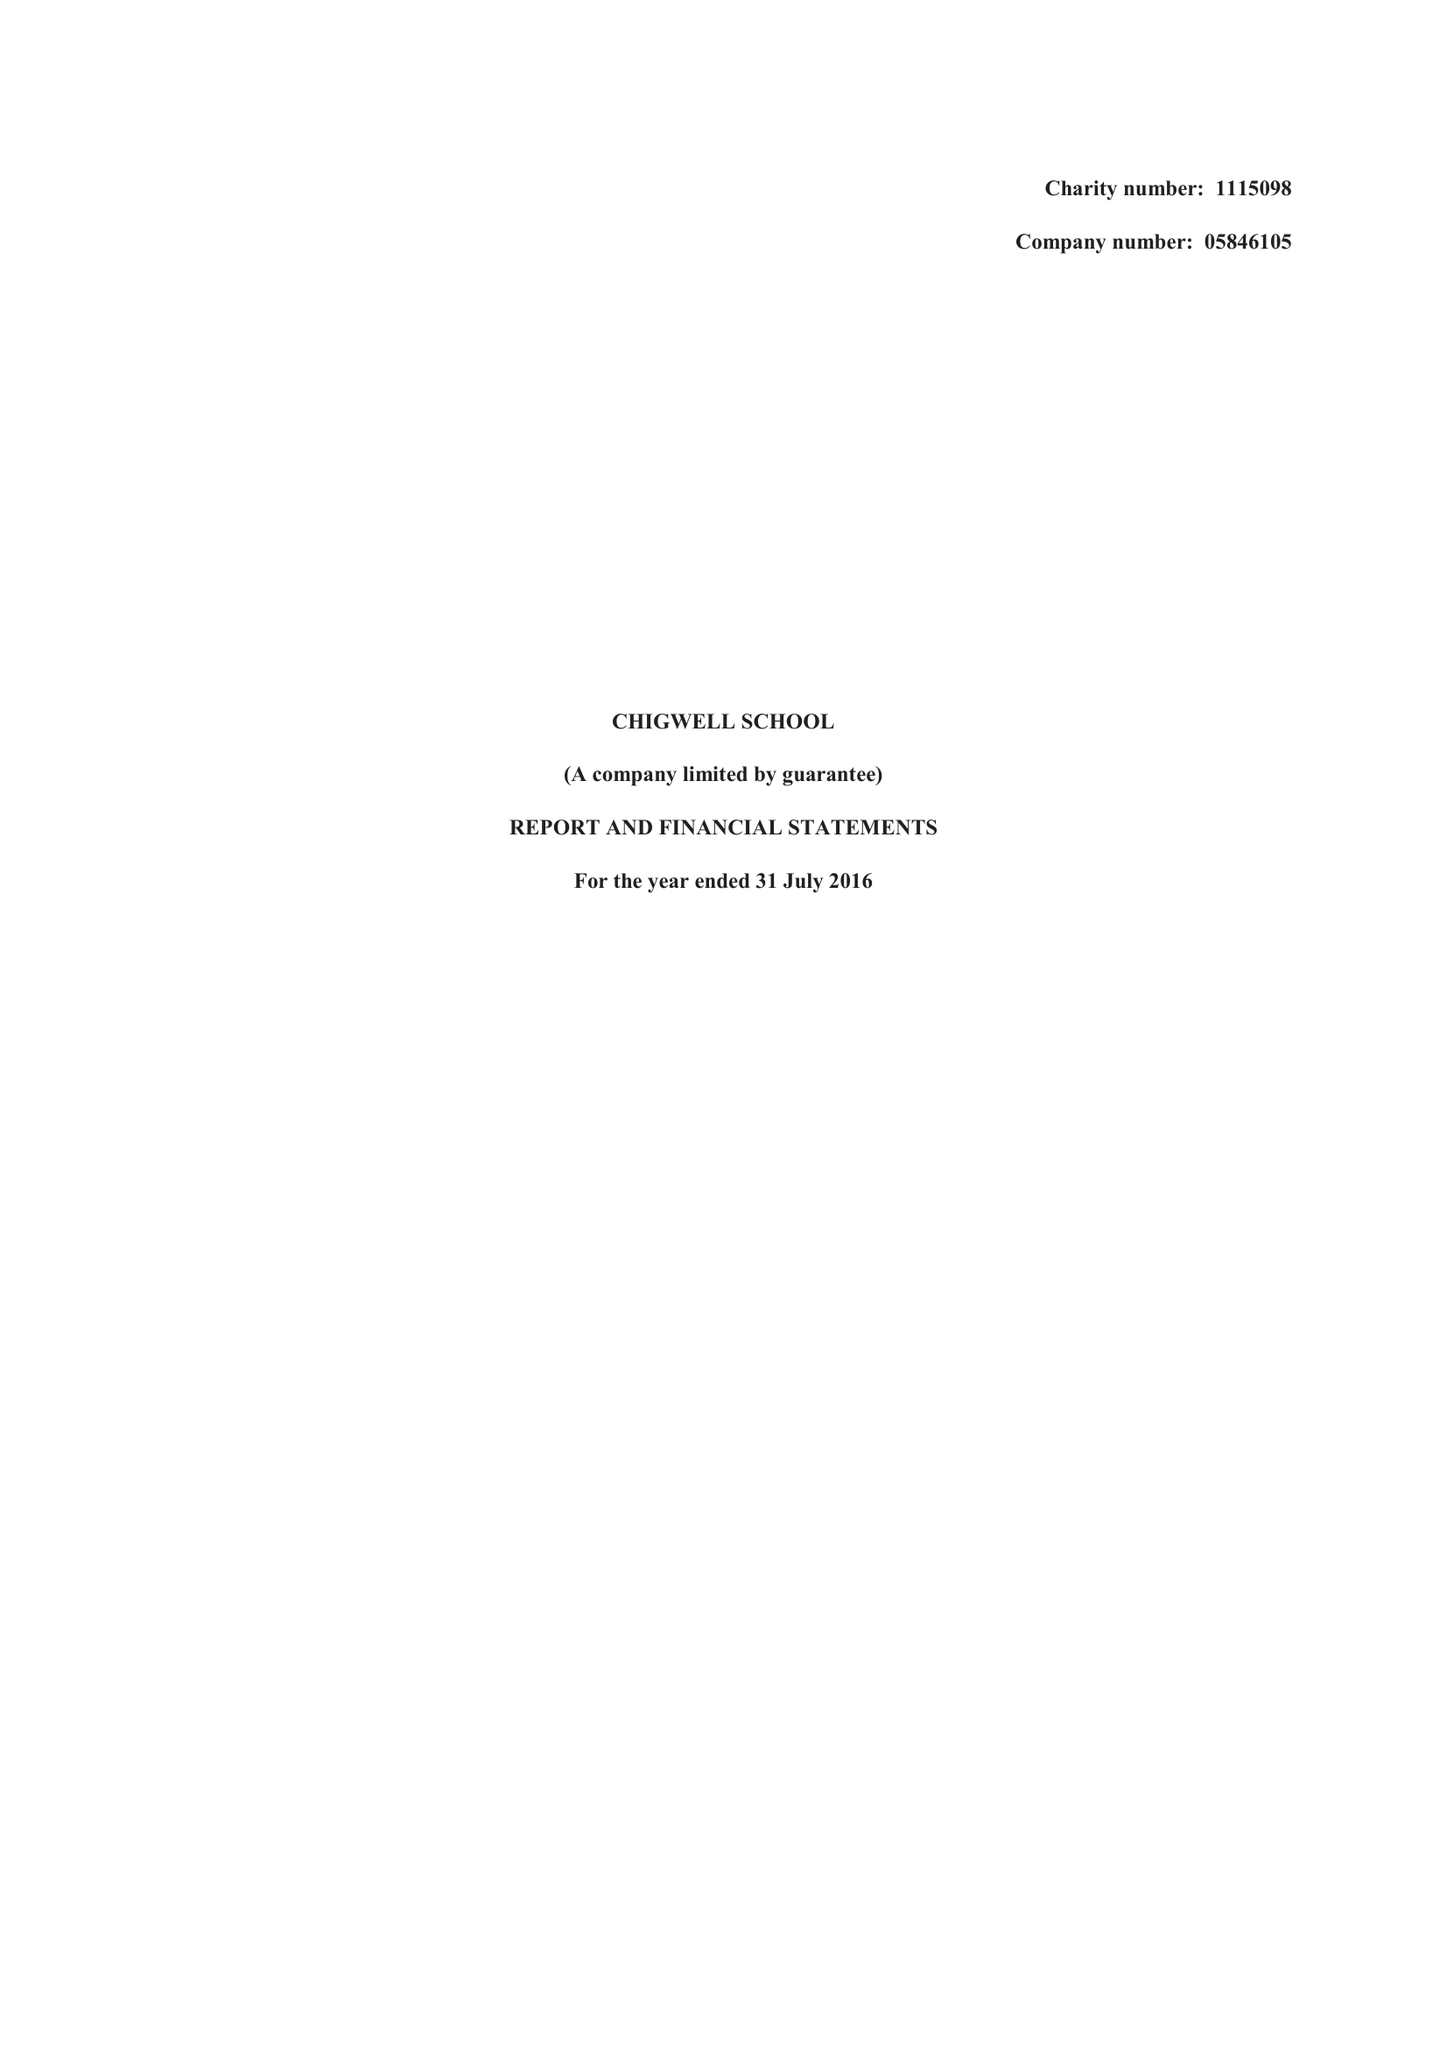What is the value for the address__postcode?
Answer the question using a single word or phrase. IG7 6QF 